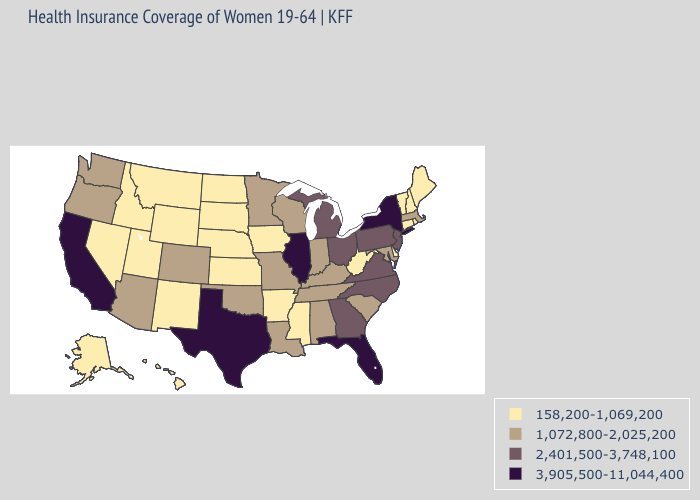Which states have the highest value in the USA?
Keep it brief. California, Florida, Illinois, New York, Texas. What is the highest value in the Northeast ?
Answer briefly. 3,905,500-11,044,400. What is the value of Mississippi?
Write a very short answer. 158,200-1,069,200. What is the value of Wisconsin?
Keep it brief. 1,072,800-2,025,200. Name the states that have a value in the range 158,200-1,069,200?
Write a very short answer. Alaska, Arkansas, Connecticut, Delaware, Hawaii, Idaho, Iowa, Kansas, Maine, Mississippi, Montana, Nebraska, Nevada, New Hampshire, New Mexico, North Dakota, Rhode Island, South Dakota, Utah, Vermont, West Virginia, Wyoming. Does Delaware have the lowest value in the South?
Concise answer only. Yes. Does New Hampshire have the lowest value in the USA?
Give a very brief answer. Yes. What is the value of Mississippi?
Write a very short answer. 158,200-1,069,200. Which states have the lowest value in the South?
Write a very short answer. Arkansas, Delaware, Mississippi, West Virginia. Does California have the highest value in the West?
Answer briefly. Yes. What is the value of Texas?
Answer briefly. 3,905,500-11,044,400. What is the lowest value in states that border Florida?
Write a very short answer. 1,072,800-2,025,200. What is the lowest value in states that border Delaware?
Quick response, please. 1,072,800-2,025,200. Is the legend a continuous bar?
Write a very short answer. No. What is the highest value in the West ?
Quick response, please. 3,905,500-11,044,400. 